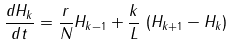Convert formula to latex. <formula><loc_0><loc_0><loc_500><loc_500>\frac { d H _ { k } } { d t } = \frac { r } { N } H _ { k - 1 } + \frac { k } { L } \, \left ( H _ { k + 1 } - H _ { k } \right )</formula> 